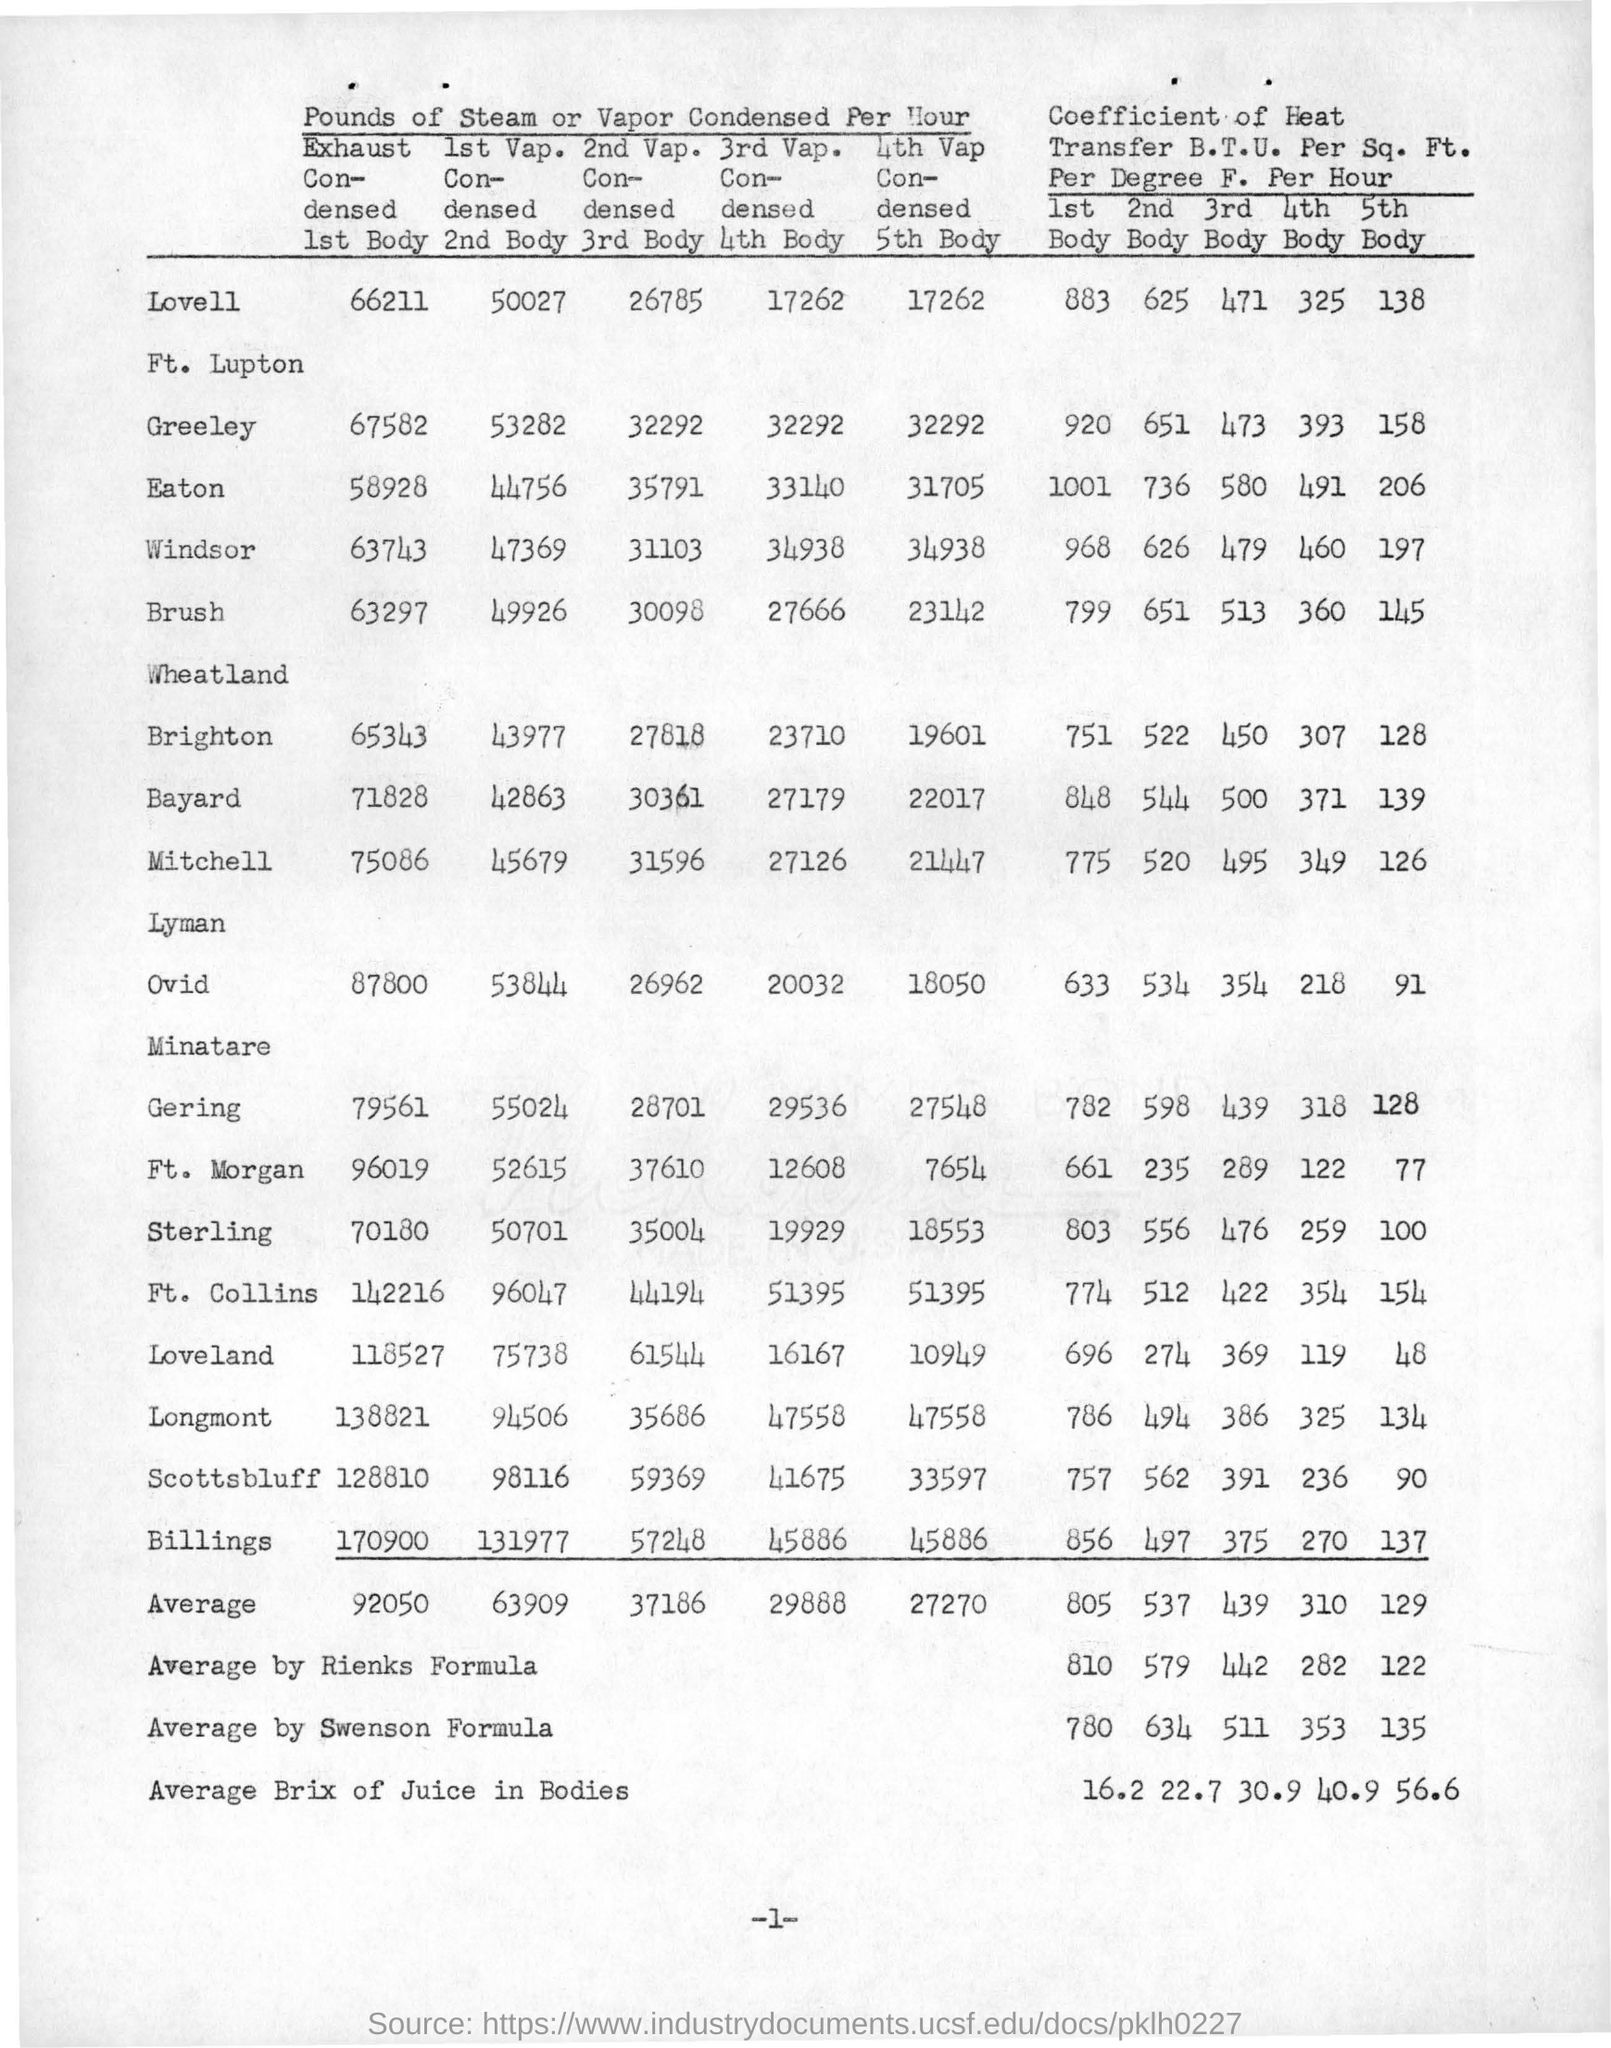Can you tell me what this image is about? The image appears to be a scanned document containing a table that details the performance metrics of steam or vapor condensed per hour in different locations. It presents both raw data and coefficients of heat transfer in British Thermal Units (B.T.U.) per Square Foot per Degree Fahrenheit per Hour for multiple 'bodies' or components of a system, presumably related to a steam condensing process. The table includes averages and specifically lists a value according to the Swenson formula, which is a method for calculating such coefficients. 